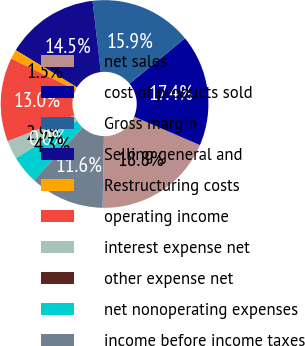<chart> <loc_0><loc_0><loc_500><loc_500><pie_chart><fcel>net sales<fcel>cost of products sold<fcel>Gross margin<fcel>Selling general and<fcel>Restructuring costs<fcel>operating income<fcel>interest expense net<fcel>other expense net<fcel>net nonoperating expenses<fcel>income before income taxes<nl><fcel>18.83%<fcel>17.38%<fcel>15.94%<fcel>14.49%<fcel>1.46%<fcel>13.04%<fcel>2.91%<fcel>0.01%<fcel>4.35%<fcel>11.59%<nl></chart> 